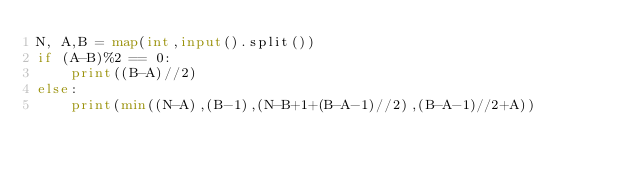Convert code to text. <code><loc_0><loc_0><loc_500><loc_500><_Python_>N, A,B = map(int,input().split())
if (A-B)%2 == 0:
    print((B-A)//2)
else:
    print(min((N-A),(B-1),(N-B+1+(B-A-1)//2),(B-A-1)//2+A))</code> 